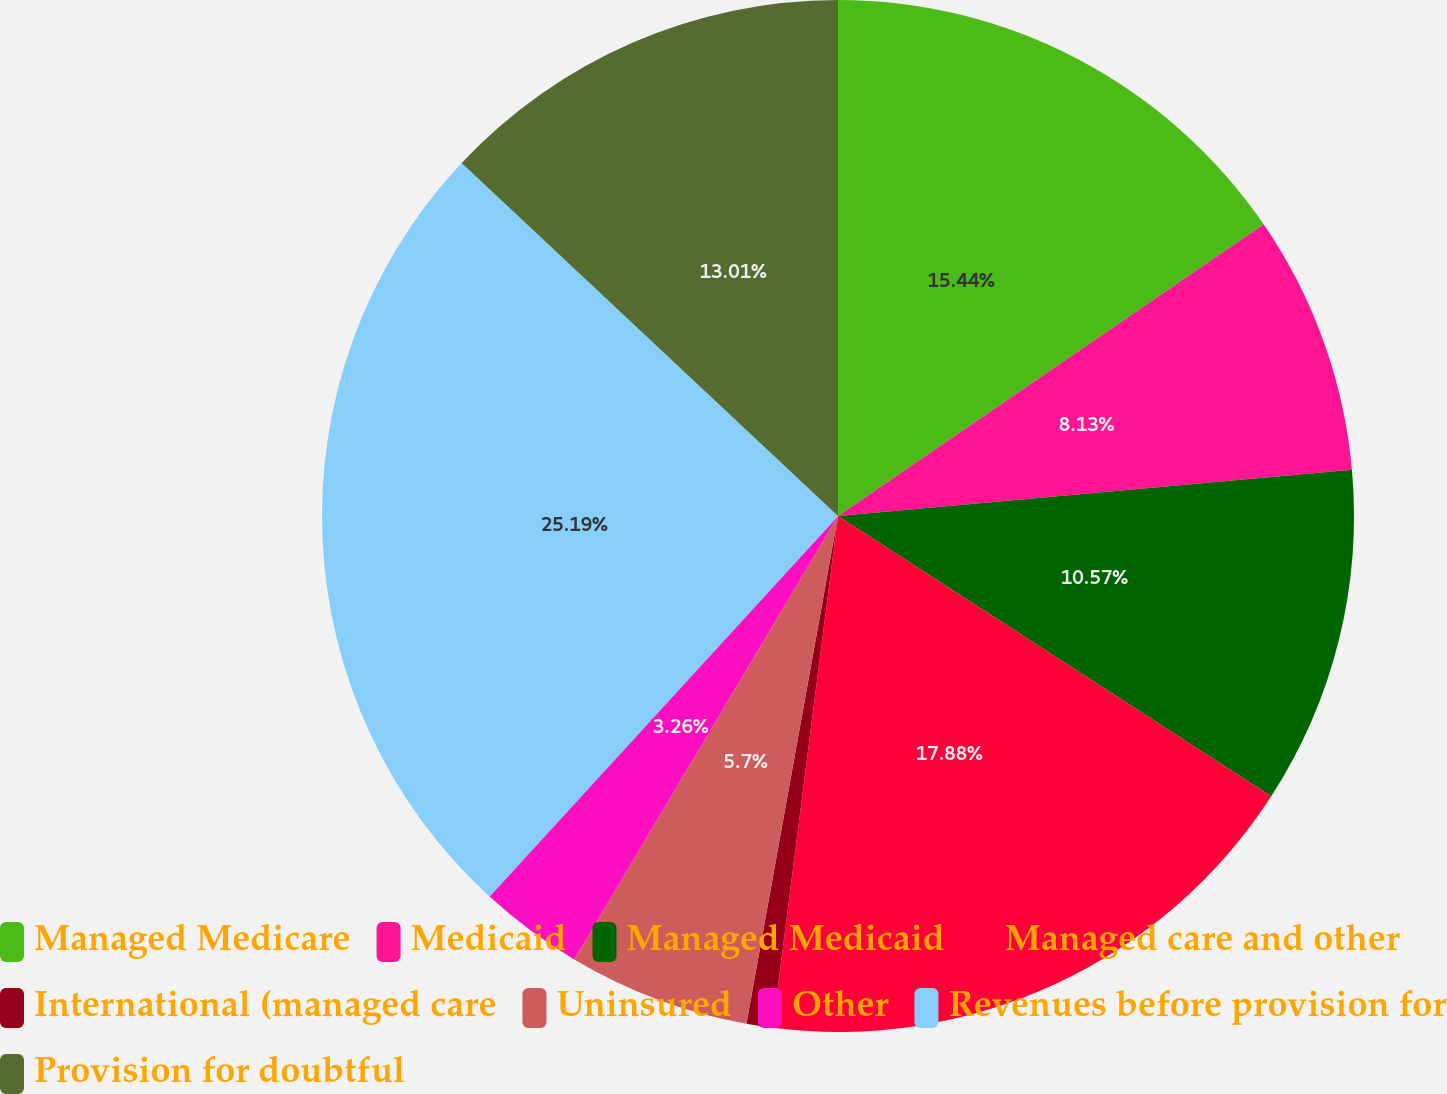<chart> <loc_0><loc_0><loc_500><loc_500><pie_chart><fcel>Managed Medicare<fcel>Medicaid<fcel>Managed Medicaid<fcel>Managed care and other<fcel>International (managed care<fcel>Uninsured<fcel>Other<fcel>Revenues before provision for<fcel>Provision for doubtful<nl><fcel>15.44%<fcel>8.13%<fcel>10.57%<fcel>17.88%<fcel>0.82%<fcel>5.7%<fcel>3.26%<fcel>25.19%<fcel>13.01%<nl></chart> 